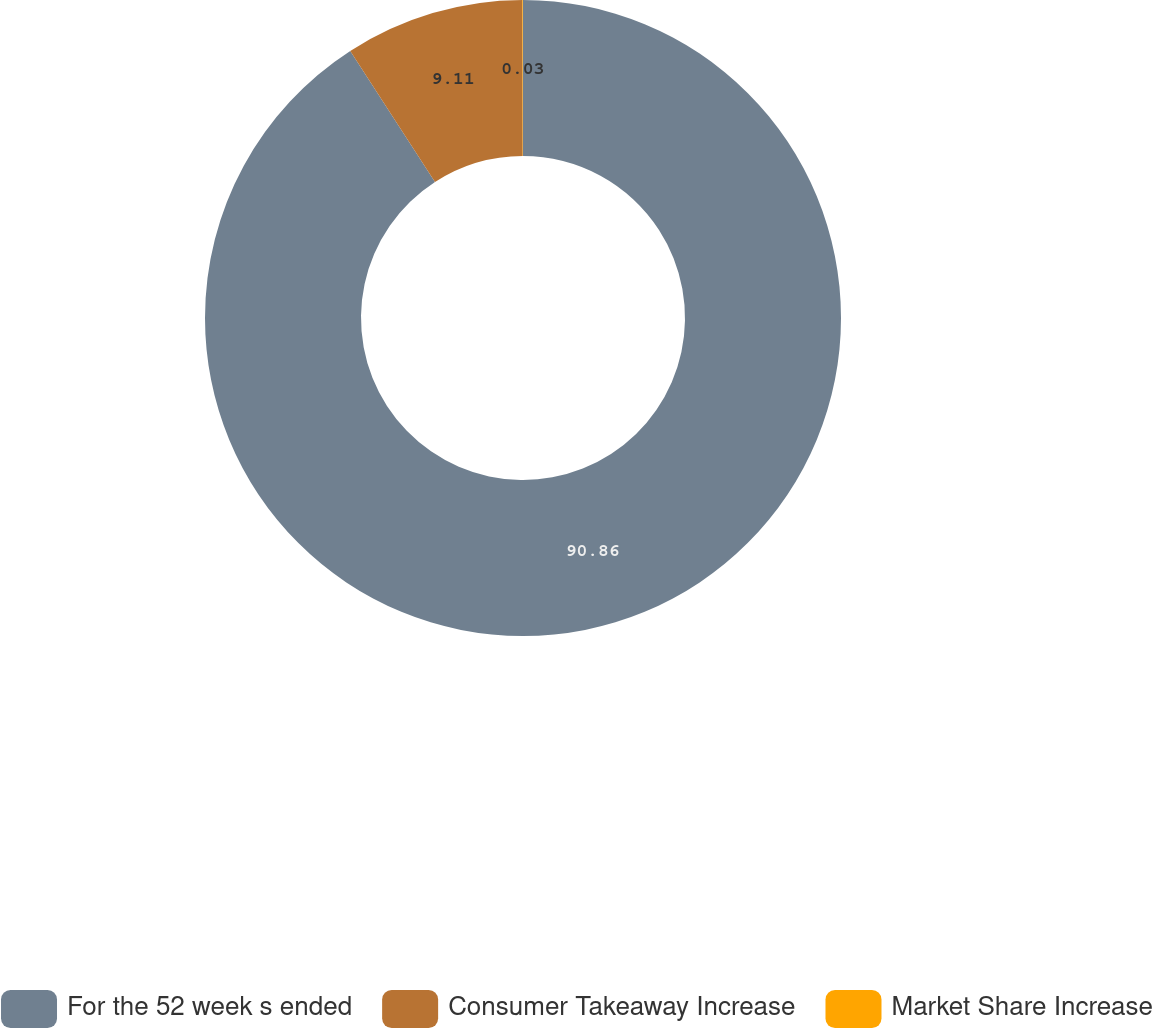Convert chart to OTSL. <chart><loc_0><loc_0><loc_500><loc_500><pie_chart><fcel>For the 52 week s ended<fcel>Consumer Takeaway Increase<fcel>Market Share Increase<nl><fcel>90.86%<fcel>9.11%<fcel>0.03%<nl></chart> 